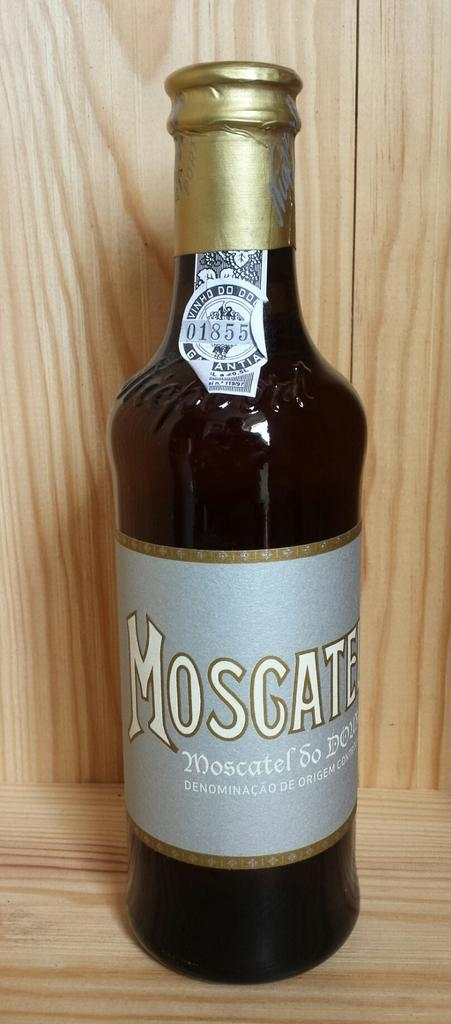<image>
Share a concise interpretation of the image provided. A glass bottle of Moscatel standing inside of a wooden cabinet. 